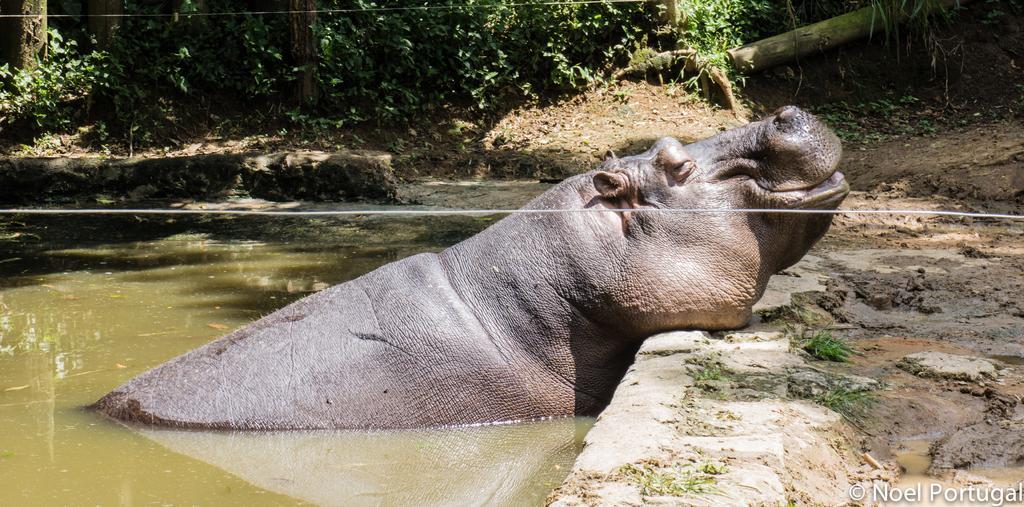Could you give a brief overview of what you see in this image? In this picture we can see a hippopotamus in the water, beside to it we can find a cable, in the background we can see few trees, at the right bottom of the image we can find a watermark. 